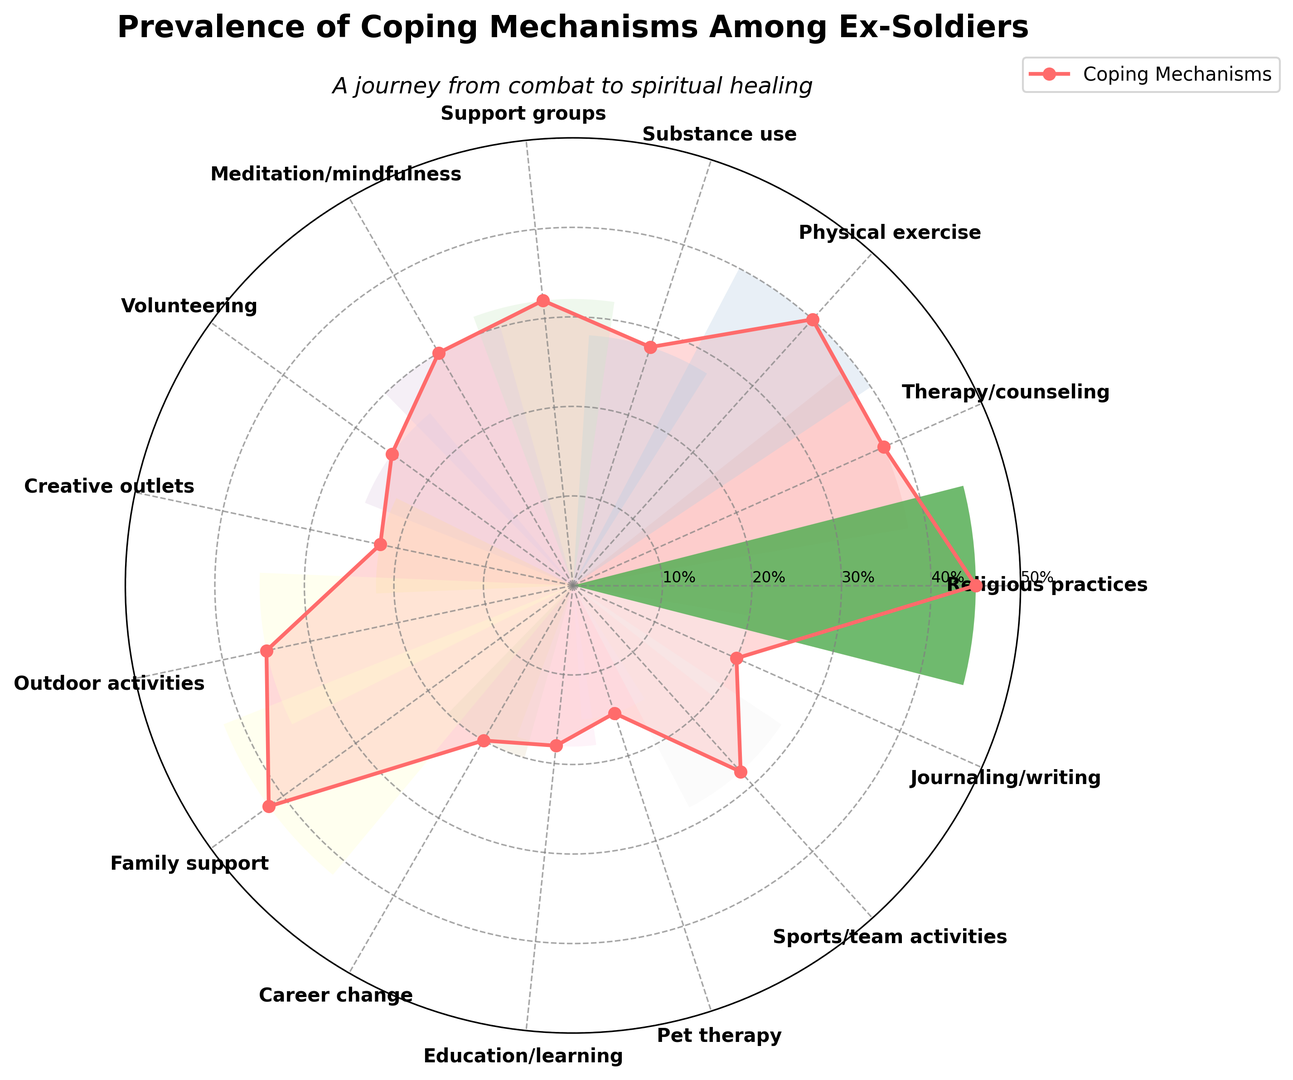What coping mechanism is the most prevalent among ex-soldiers? Religious practices have the highest percentage in the radar chart. A visual inspection confirms that "Religious practices" have the tallest segment extending to 45%.
Answer: Religious practices Which coping mechanism is less prevalent: meditation/mindfulness or volunteering? Meditation/mindfulness has a percentage of 30%, while volunteering has a percentage of 25%. Comparing these two values visually, meditation/mindfulness has a higher segment than volunteering.
Answer: Volunteering How does the prevalence of support groups compare to family support? Support groups have a percentage of 32%, and family support has a percentage of 42%. By looking at the radar chart, the segment for family support extends further out than that for support groups.
Answer: Family support is more prevalent What is the combined prevalence of therapy/counseling and substance use? Therapy/counseling has a percentage of 38% and substance use has a percentage of 28%. Summing these values, 38% + 28% gives a combined prevalence of 66%.
Answer: 66% Which coping mechanism has a higher prevalence, career change or journaling/writing? Career change has a prevalence of 20%, and journaling/writing also has a prevalence of 20%. Both extend out equally in the radar chart, indicating they have the same prevalence.
Answer: Both have the same prevalence What’s the average prevalence of physical exercise, pet therapy, and sports/team activities? Physical exercise has a prevalence of 40%, pet therapy has a prevalence of 15%, and sports/team activities have a prevalence of 28%. Sum these values (40% + 15% + 28%) which equals 83%. Then, divide by the number of elements (83% / 3) to get the average, which is approximately 27.67%.
Answer: 27.67% Compare the prevalence of outdoor activities to creative outlets. Outdoor activities have a percentage of 35% while creative outlets have a percentage of 22%. Visually, the segment for outdoor activities extends further out than that for creative outlets.
Answer: Outdoor activities has a higher prevalence 